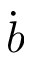<formula> <loc_0><loc_0><loc_500><loc_500>\dot { b }</formula> 